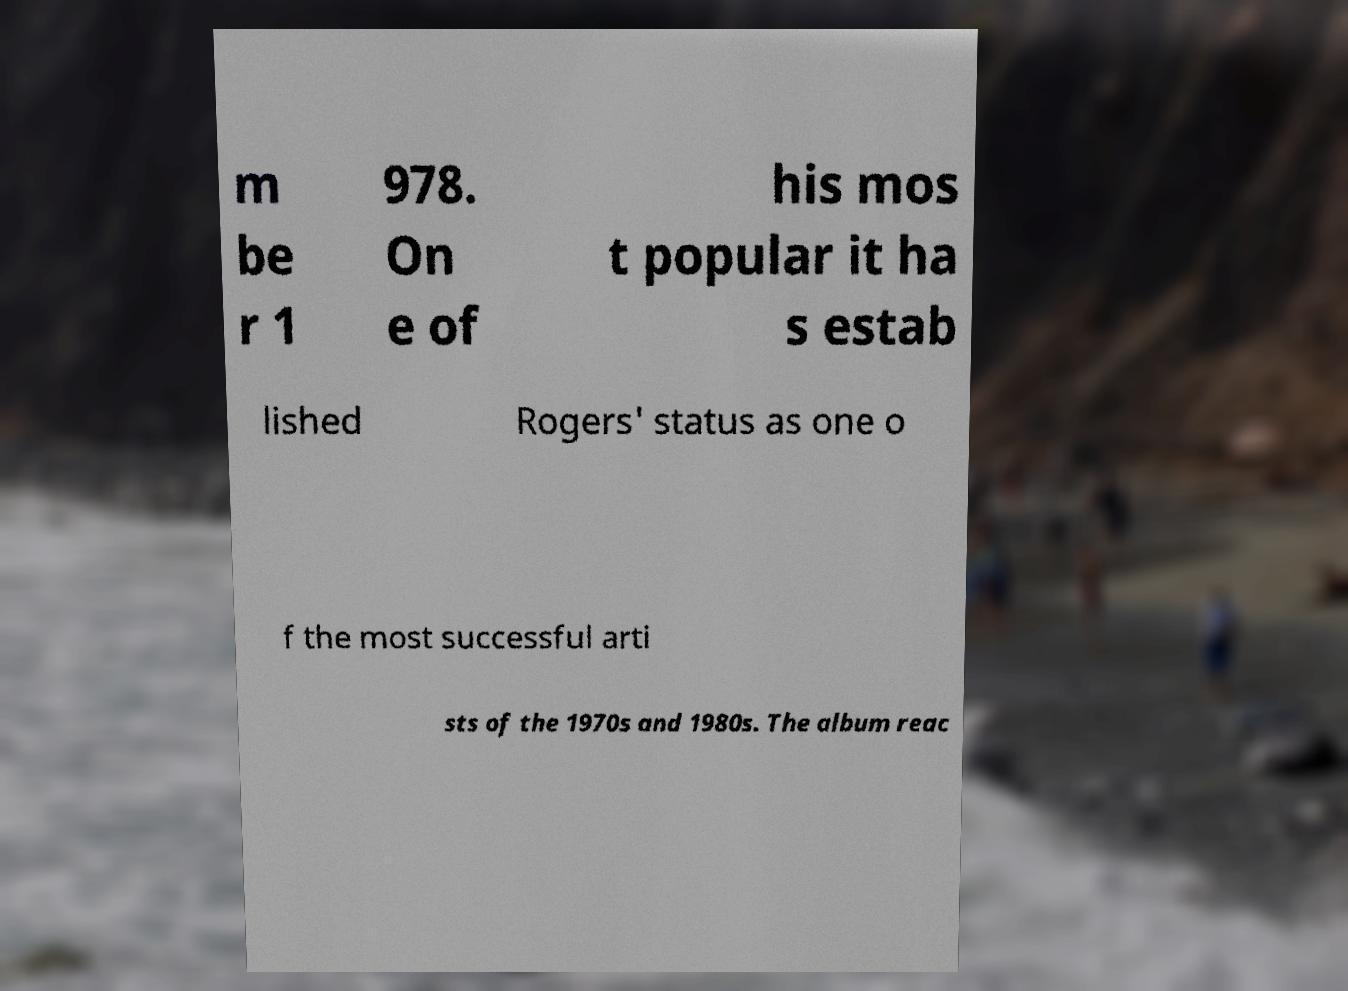Can you accurately transcribe the text from the provided image for me? m be r 1 978. On e of his mos t popular it ha s estab lished Rogers' status as one o f the most successful arti sts of the 1970s and 1980s. The album reac 